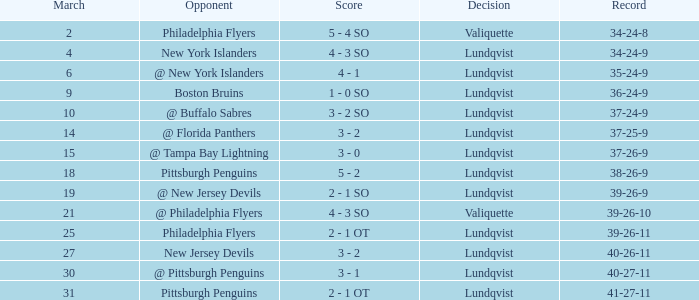Which opponent's game was less than 76 when the march was 10? @ Buffalo Sabres. 